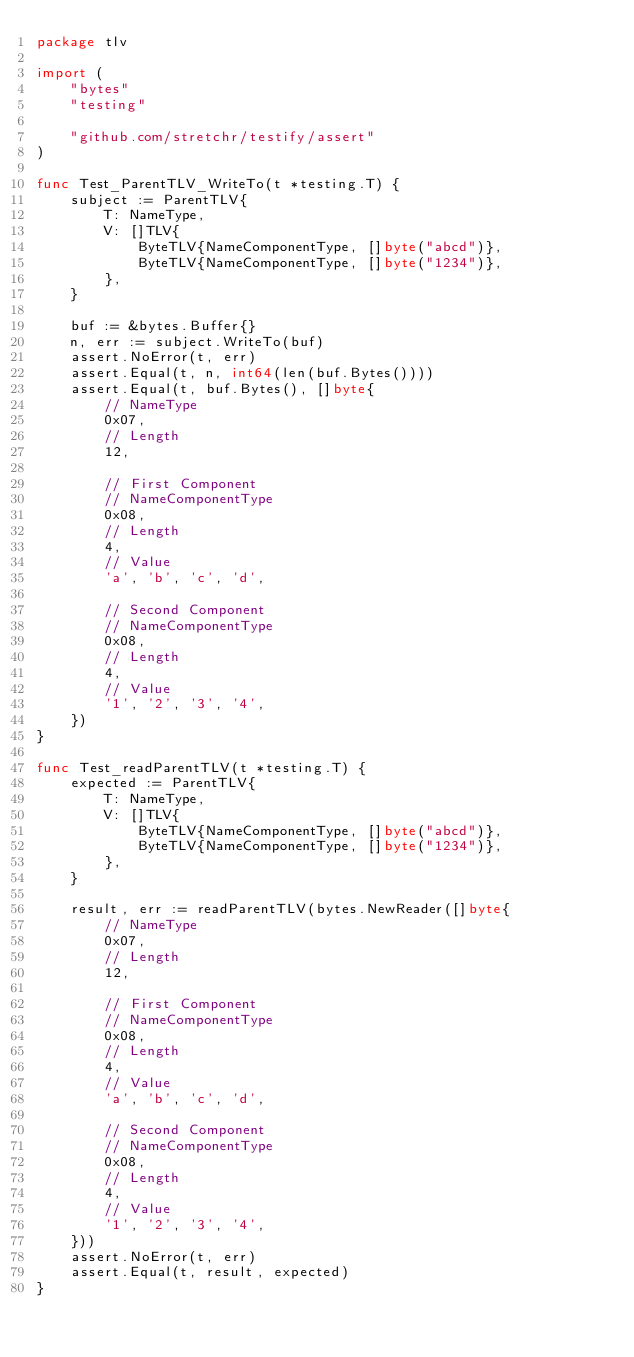Convert code to text. <code><loc_0><loc_0><loc_500><loc_500><_Go_>package tlv

import (
	"bytes"
	"testing"

	"github.com/stretchr/testify/assert"
)

func Test_ParentTLV_WriteTo(t *testing.T) {
	subject := ParentTLV{
		T: NameType,
		V: []TLV{
			ByteTLV{NameComponentType, []byte("abcd")},
			ByteTLV{NameComponentType, []byte("1234")},
		},
	}

	buf := &bytes.Buffer{}
	n, err := subject.WriteTo(buf)
	assert.NoError(t, err)
	assert.Equal(t, n, int64(len(buf.Bytes())))
	assert.Equal(t, buf.Bytes(), []byte{
		// NameType
		0x07,
		// Length
		12,

		// First Component
		// NameComponentType
		0x08,
		// Length
		4,
		// Value
		'a', 'b', 'c', 'd',

		// Second Component
		// NameComponentType
		0x08,
		// Length
		4,
		// Value
		'1', '2', '3', '4',
	})
}

func Test_readParentTLV(t *testing.T) {
	expected := ParentTLV{
		T: NameType,
		V: []TLV{
			ByteTLV{NameComponentType, []byte("abcd")},
			ByteTLV{NameComponentType, []byte("1234")},
		},
	}

	result, err := readParentTLV(bytes.NewReader([]byte{
		// NameType
		0x07,
		// Length
		12,

		// First Component
		// NameComponentType
		0x08,
		// Length
		4,
		// Value
		'a', 'b', 'c', 'd',

		// Second Component
		// NameComponentType
		0x08,
		// Length
		4,
		// Value
		'1', '2', '3', '4',
	}))
	assert.NoError(t, err)
	assert.Equal(t, result, expected)
}
</code> 